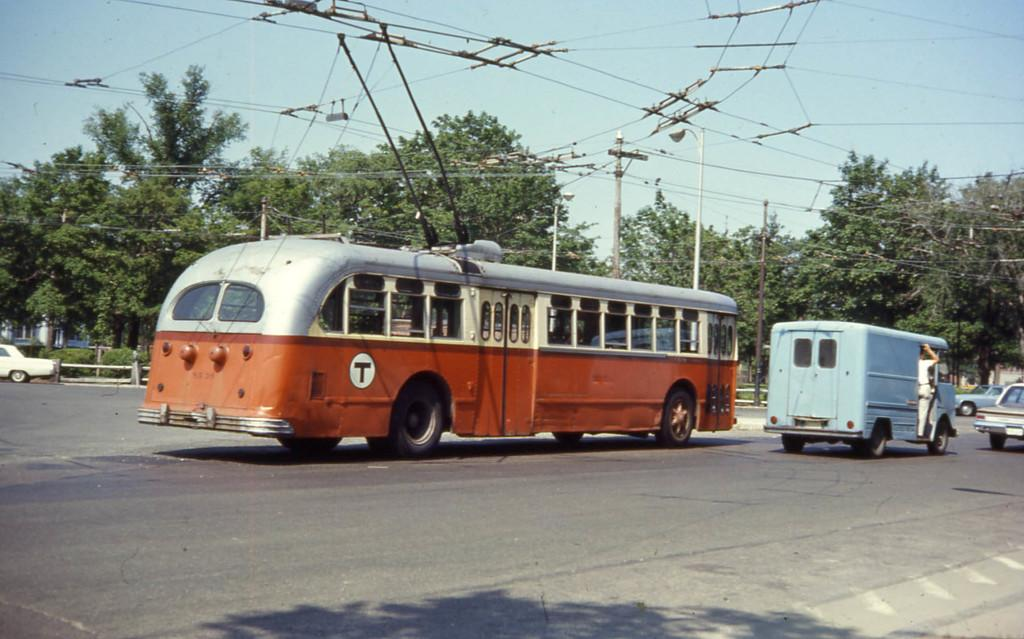What can be seen on the road in the image? There are vehicles on the road in the image. What is present above the road in the image? There are wires above the road in the image. What type of natural scenery is visible in the background of the image? There are trees in the background of the image. Where is the map located in the image? There is no map present in the image. Can you see an airplane flying in the sky in the image? The sky is not visible in the image, so it is impossible to determine if an airplane is flying. Is there any honey dripping from the trees in the background of the image? There is no honey present in the image; it features vehicles on the road, wires above the road, and trees in the background. 